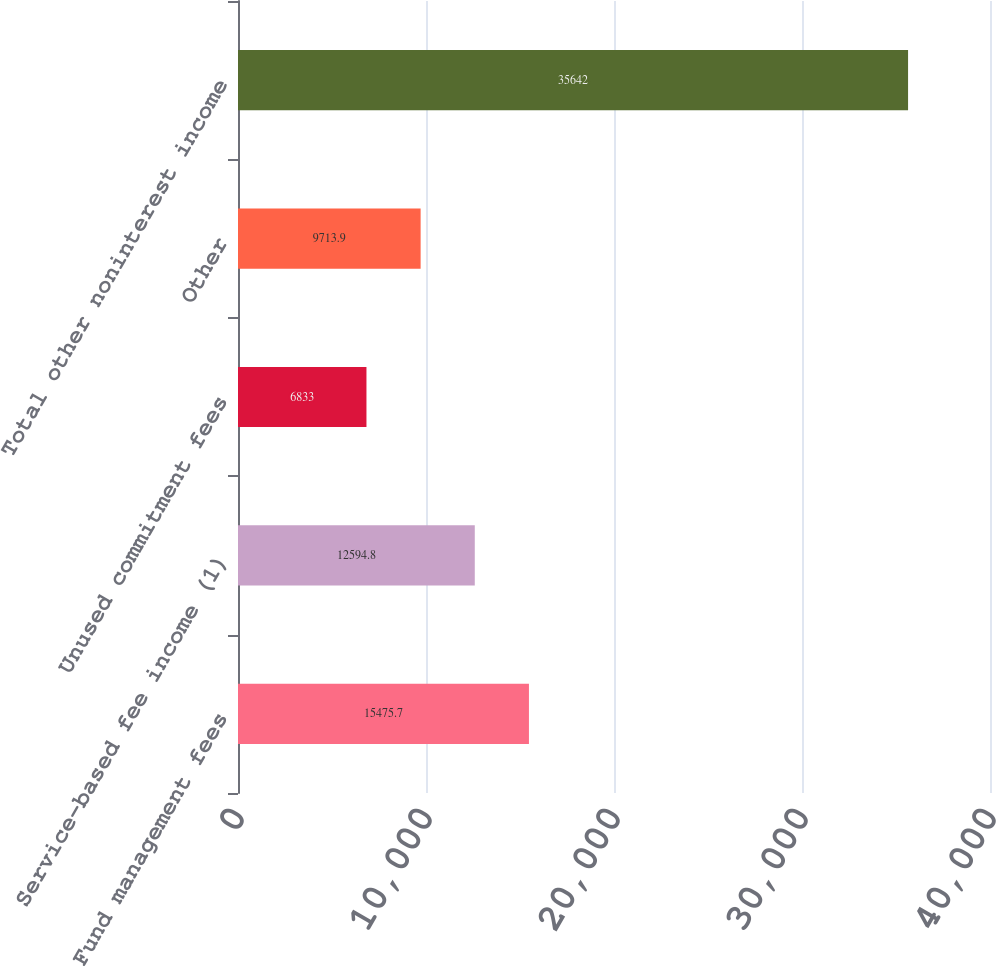<chart> <loc_0><loc_0><loc_500><loc_500><bar_chart><fcel>Fund management fees<fcel>Service-based fee income (1)<fcel>Unused commitment fees<fcel>Other<fcel>Total other noninterest income<nl><fcel>15475.7<fcel>12594.8<fcel>6833<fcel>9713.9<fcel>35642<nl></chart> 